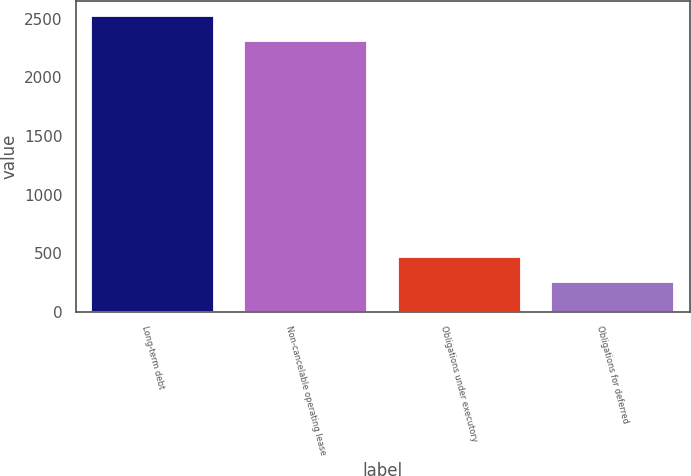Convert chart. <chart><loc_0><loc_0><loc_500><loc_500><bar_chart><fcel>Long-term debt<fcel>Non-cancelable operating lease<fcel>Obligations under executory<fcel>Obligations for deferred<nl><fcel>2526<fcel>2307.6<fcel>470.6<fcel>252.2<nl></chart> 